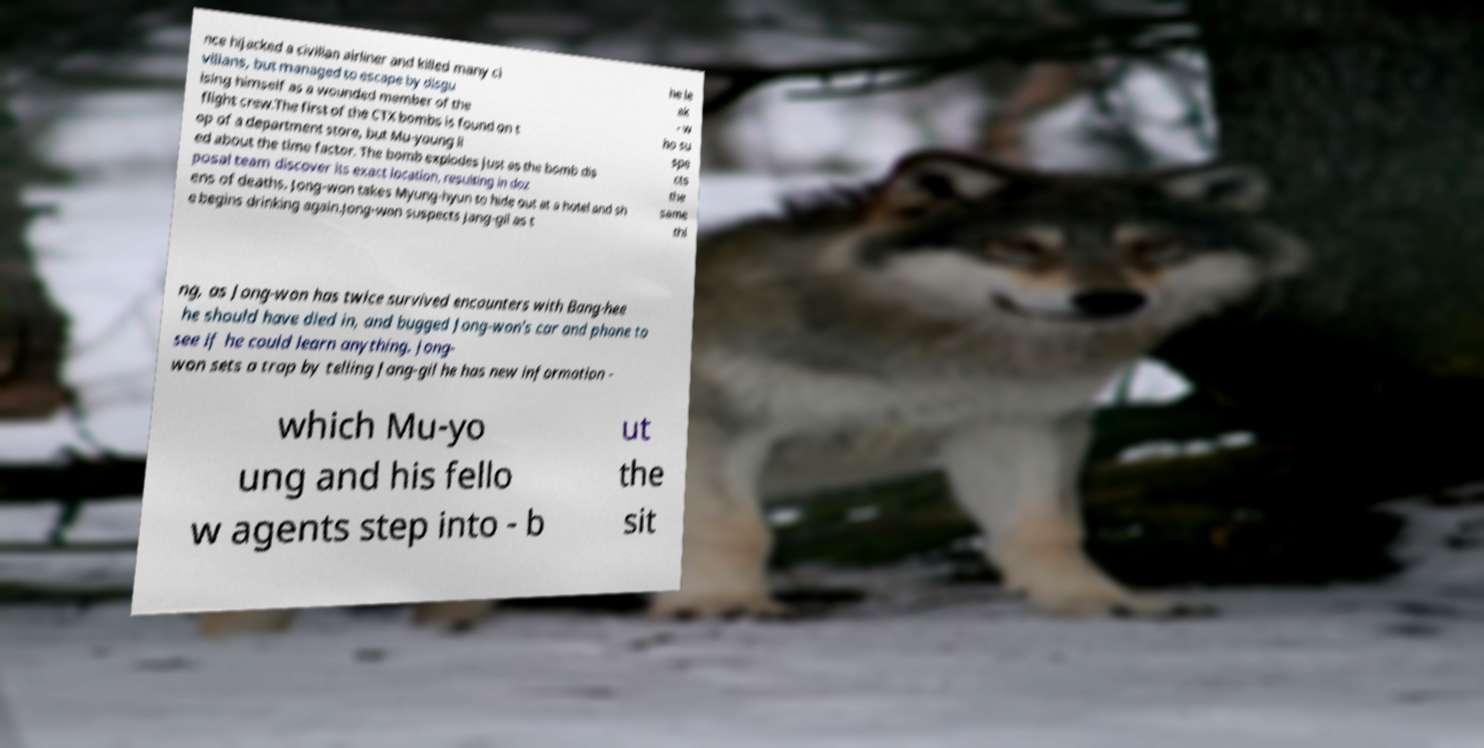Can you accurately transcribe the text from the provided image for me? nce hijacked a civilian airliner and killed many ci vilians, but managed to escape by disgu ising himself as a wounded member of the flight crew.The first of the CTX bombs is found on t op of a department store, but Mu-young li ed about the time factor. The bomb explodes just as the bomb dis posal team discover its exact location, resulting in doz ens of deaths. Jong-won takes Myung-hyun to hide out at a hotel and sh e begins drinking again.Jong-won suspects Jang-gil as t he le ak - w ho su spe cts the same thi ng, as Jong-won has twice survived encounters with Bang-hee he should have died in, and bugged Jong-won's car and phone to see if he could learn anything. Jong- won sets a trap by telling Jang-gil he has new information - which Mu-yo ung and his fello w agents step into - b ut the sit 